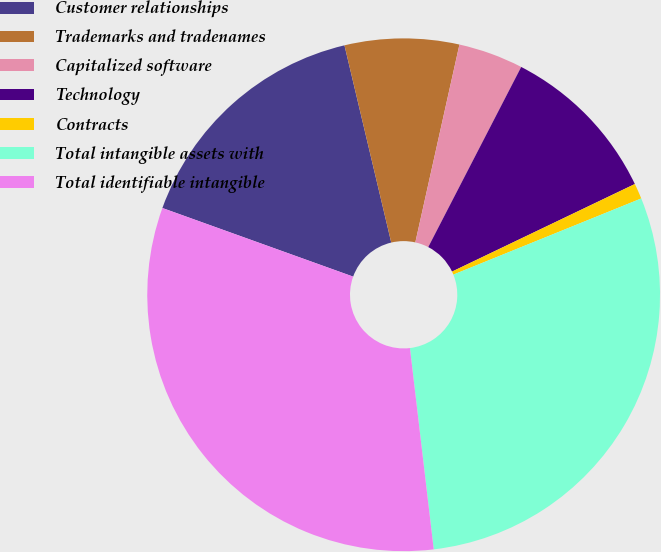<chart> <loc_0><loc_0><loc_500><loc_500><pie_chart><fcel>Customer relationships<fcel>Trademarks and tradenames<fcel>Capitalized software<fcel>Technology<fcel>Contracts<fcel>Total intangible assets with<fcel>Total identifiable intangible<nl><fcel>15.8%<fcel>7.2%<fcel>4.09%<fcel>10.31%<fcel>0.98%<fcel>29.26%<fcel>32.37%<nl></chart> 